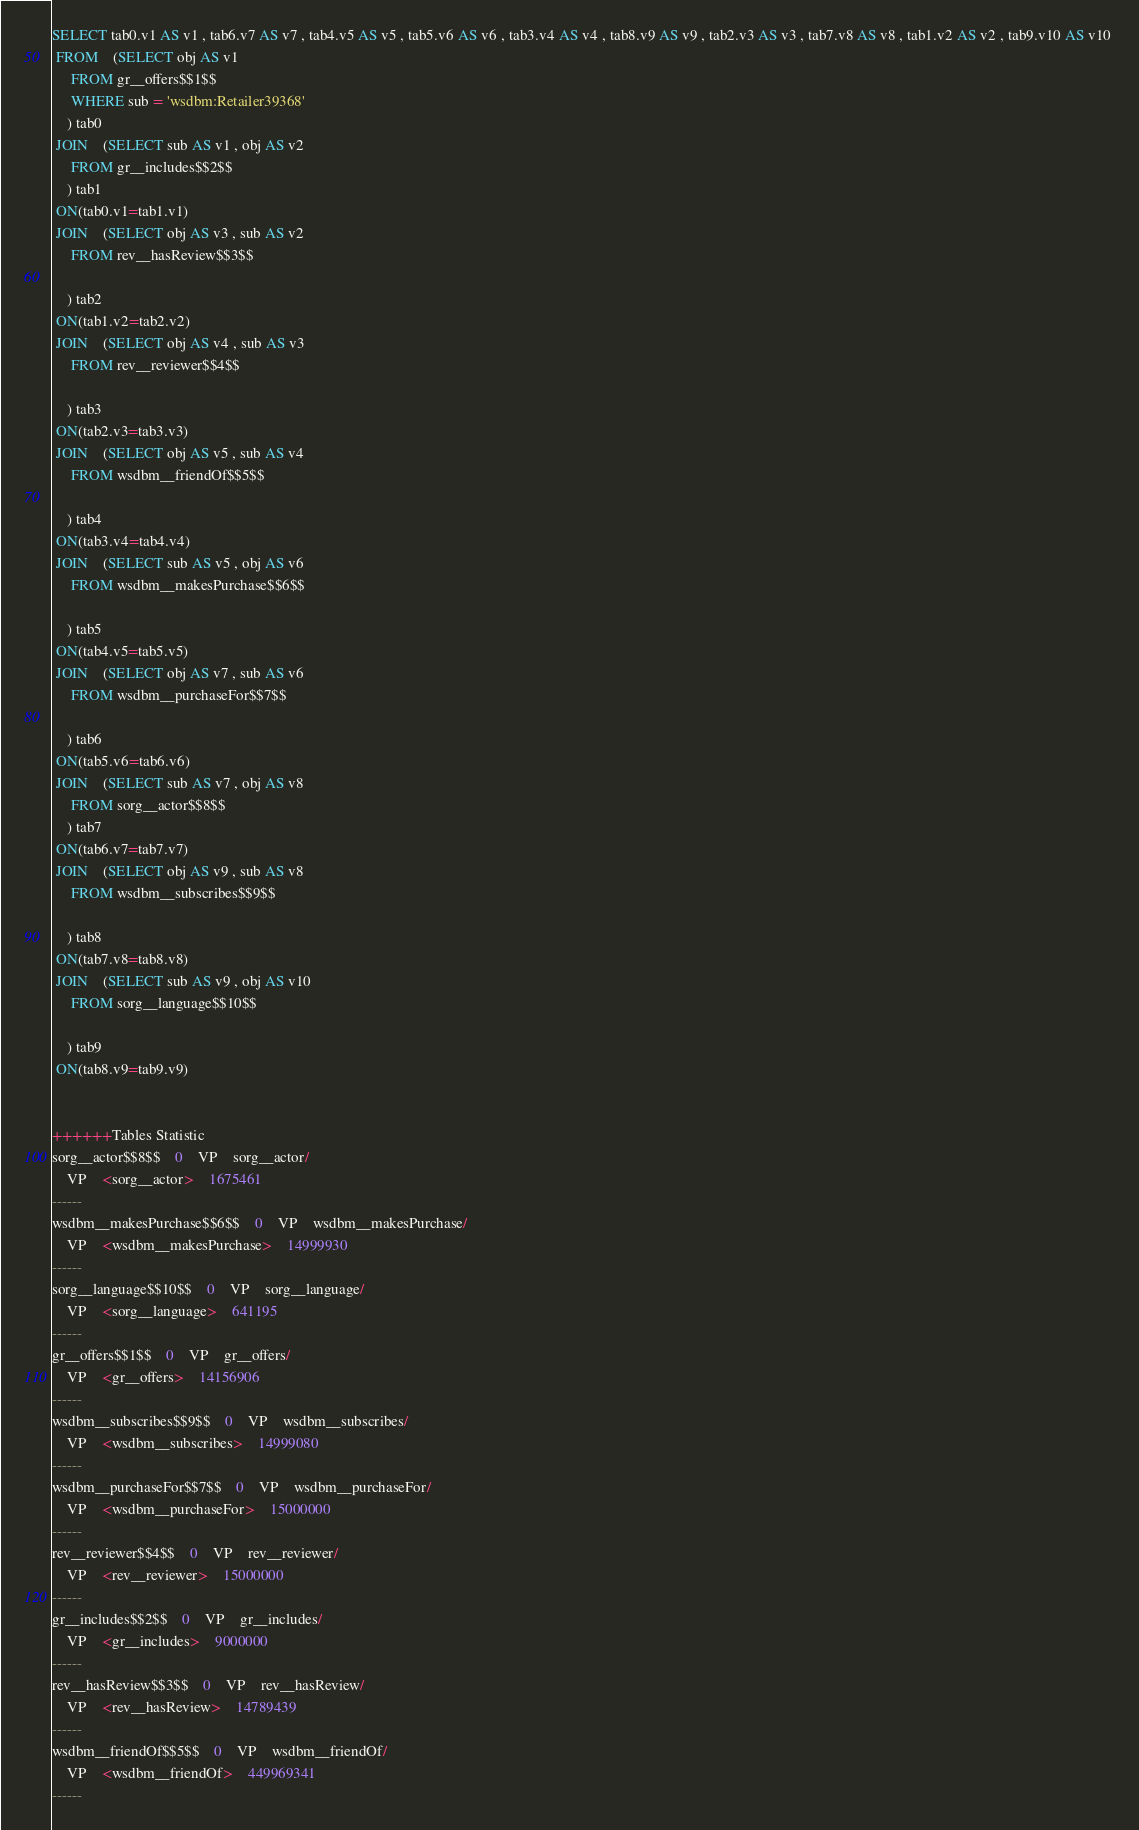Convert code to text. <code><loc_0><loc_0><loc_500><loc_500><_SQL_>SELECT tab0.v1 AS v1 , tab6.v7 AS v7 , tab4.v5 AS v5 , tab5.v6 AS v6 , tab3.v4 AS v4 , tab8.v9 AS v9 , tab2.v3 AS v3 , tab7.v8 AS v8 , tab1.v2 AS v2 , tab9.v10 AS v10 
 FROM    (SELECT obj AS v1 
	 FROM gr__offers$$1$$ 
	 WHERE sub = 'wsdbm:Retailer39368'
	) tab0
 JOIN    (SELECT sub AS v1 , obj AS v2 
	 FROM gr__includes$$2$$
	) tab1
 ON(tab0.v1=tab1.v1)
 JOIN    (SELECT obj AS v3 , sub AS v2 
	 FROM rev__hasReview$$3$$
	
	) tab2
 ON(tab1.v2=tab2.v2)
 JOIN    (SELECT obj AS v4 , sub AS v3 
	 FROM rev__reviewer$$4$$
	
	) tab3
 ON(tab2.v3=tab3.v3)
 JOIN    (SELECT obj AS v5 , sub AS v4 
	 FROM wsdbm__friendOf$$5$$
	
	) tab4
 ON(tab3.v4=tab4.v4)
 JOIN    (SELECT sub AS v5 , obj AS v6 
	 FROM wsdbm__makesPurchase$$6$$
	
	) tab5
 ON(tab4.v5=tab5.v5)
 JOIN    (SELECT obj AS v7 , sub AS v6 
	 FROM wsdbm__purchaseFor$$7$$
	
	) tab6
 ON(tab5.v6=tab6.v6)
 JOIN    (SELECT sub AS v7 , obj AS v8 
	 FROM sorg__actor$$8$$
	) tab7
 ON(tab6.v7=tab7.v7)
 JOIN    (SELECT obj AS v9 , sub AS v8 
	 FROM wsdbm__subscribes$$9$$
	
	) tab8
 ON(tab7.v8=tab8.v8)
 JOIN    (SELECT sub AS v9 , obj AS v10 
	 FROM sorg__language$$10$$
	
	) tab9
 ON(tab8.v9=tab9.v9)


++++++Tables Statistic
sorg__actor$$8$$	0	VP	sorg__actor/
	VP	<sorg__actor>	1675461
------
wsdbm__makesPurchase$$6$$	0	VP	wsdbm__makesPurchase/
	VP	<wsdbm__makesPurchase>	14999930
------
sorg__language$$10$$	0	VP	sorg__language/
	VP	<sorg__language>	641195
------
gr__offers$$1$$	0	VP	gr__offers/
	VP	<gr__offers>	14156906
------
wsdbm__subscribes$$9$$	0	VP	wsdbm__subscribes/
	VP	<wsdbm__subscribes>	14999080
------
wsdbm__purchaseFor$$7$$	0	VP	wsdbm__purchaseFor/
	VP	<wsdbm__purchaseFor>	15000000
------
rev__reviewer$$4$$	0	VP	rev__reviewer/
	VP	<rev__reviewer>	15000000
------
gr__includes$$2$$	0	VP	gr__includes/
	VP	<gr__includes>	9000000
------
rev__hasReview$$3$$	0	VP	rev__hasReview/
	VP	<rev__hasReview>	14789439
------
wsdbm__friendOf$$5$$	0	VP	wsdbm__friendOf/
	VP	<wsdbm__friendOf>	449969341
------
</code> 